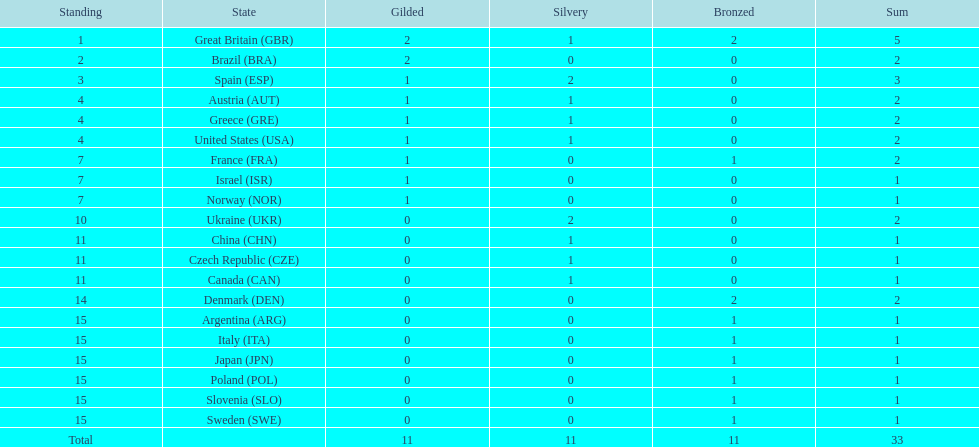What was the number of silver medals won by ukraine? 2. 